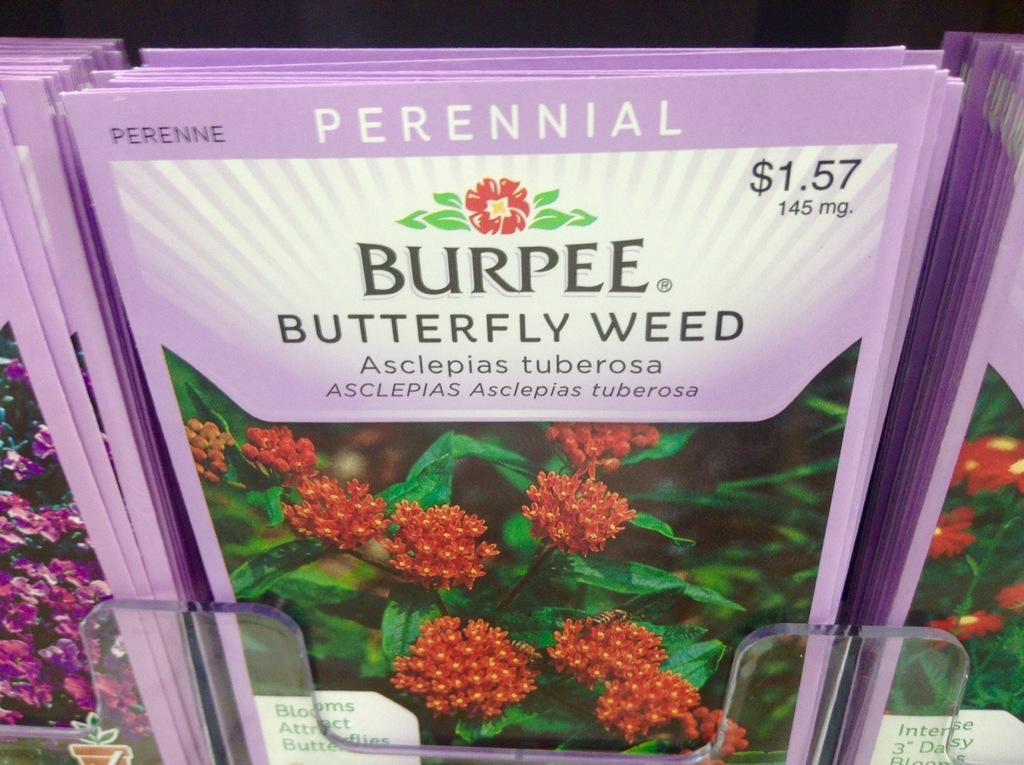What can be found on the racks in the image? There is a pamphlet on the racks in the image. How would you describe the lighting at the top of the image? The top of the image appears to be dark. What type of content is featured in the pamphlet? The pamphlet contains images of flowers and plants. Is there any text on the pamphlet besides the images? Yes, there is a quotation on the pamphlet. What type of meat is being sold in the image? There is no meat present in the image; it features a pamphlet with images of flowers and plants. Can you see any jellyfish in the image? No, there are no jellyfish present in the image. 